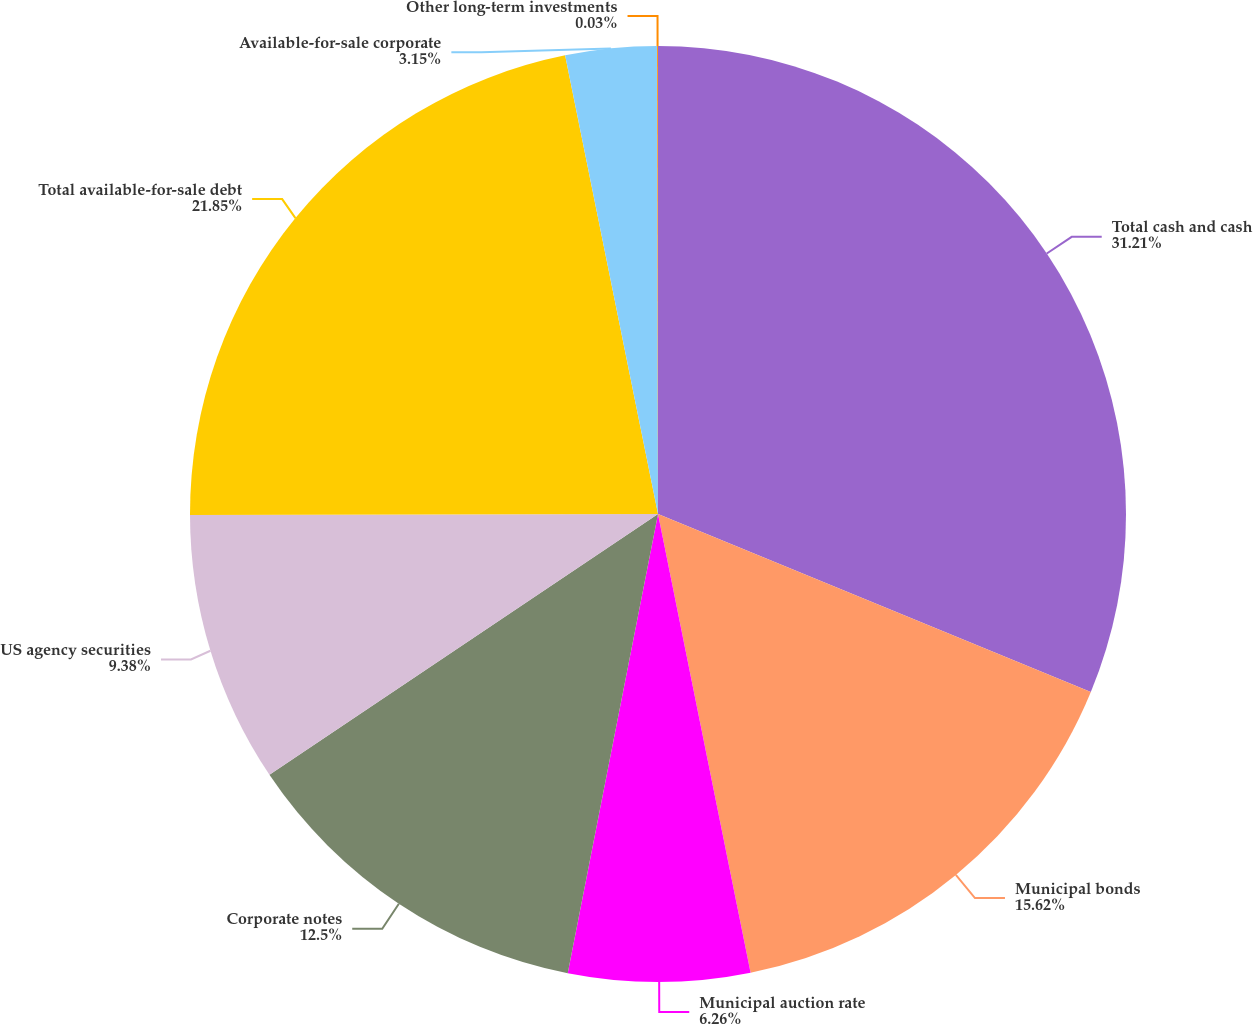Convert chart to OTSL. <chart><loc_0><loc_0><loc_500><loc_500><pie_chart><fcel>Total cash and cash<fcel>Municipal bonds<fcel>Municipal auction rate<fcel>Corporate notes<fcel>US agency securities<fcel>Total available-for-sale debt<fcel>Available-for-sale corporate<fcel>Other long-term investments<nl><fcel>31.21%<fcel>15.62%<fcel>6.26%<fcel>12.5%<fcel>9.38%<fcel>21.85%<fcel>3.15%<fcel>0.03%<nl></chart> 